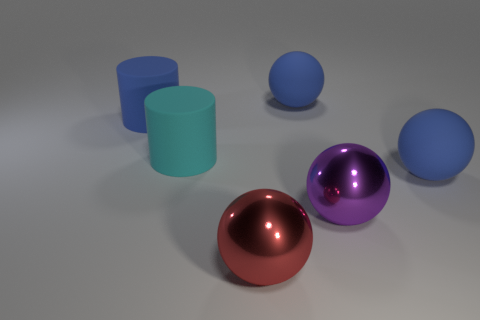Subtract all large purple shiny balls. How many balls are left? 3 Subtract all cyan cylinders. How many cylinders are left? 1 Subtract all red spheres. Subtract all purple cubes. How many spheres are left? 3 Subtract all balls. How many objects are left? 2 Subtract all blue blocks. How many red spheres are left? 1 Subtract all big matte things. Subtract all large red balls. How many objects are left? 1 Add 4 big purple objects. How many big purple objects are left? 5 Add 3 big red rubber cylinders. How many big red rubber cylinders exist? 3 Add 3 large purple metallic objects. How many objects exist? 9 Subtract 0 red cylinders. How many objects are left? 6 